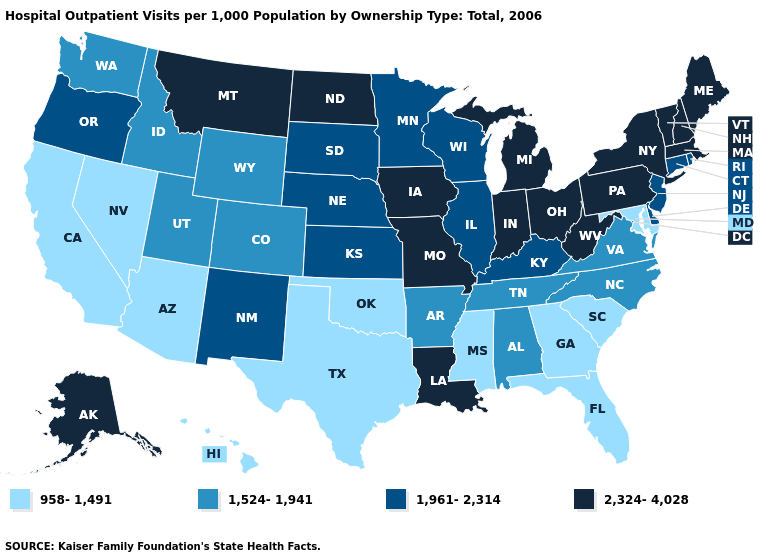Which states have the lowest value in the Northeast?
Give a very brief answer. Connecticut, New Jersey, Rhode Island. Does North Carolina have the same value as Wisconsin?
Keep it brief. No. Name the states that have a value in the range 1,961-2,314?
Be succinct. Connecticut, Delaware, Illinois, Kansas, Kentucky, Minnesota, Nebraska, New Jersey, New Mexico, Oregon, Rhode Island, South Dakota, Wisconsin. Does Oregon have the lowest value in the West?
Be succinct. No. What is the value of Massachusetts?
Answer briefly. 2,324-4,028. What is the highest value in the USA?
Short answer required. 2,324-4,028. Among the states that border Kentucky , does Ohio have the highest value?
Answer briefly. Yes. Among the states that border New Mexico , does Texas have the highest value?
Keep it brief. No. What is the value of Florida?
Quick response, please. 958-1,491. What is the value of Oregon?
Answer briefly. 1,961-2,314. Name the states that have a value in the range 1,524-1,941?
Answer briefly. Alabama, Arkansas, Colorado, Idaho, North Carolina, Tennessee, Utah, Virginia, Washington, Wyoming. Name the states that have a value in the range 958-1,491?
Write a very short answer. Arizona, California, Florida, Georgia, Hawaii, Maryland, Mississippi, Nevada, Oklahoma, South Carolina, Texas. Name the states that have a value in the range 1,961-2,314?
Answer briefly. Connecticut, Delaware, Illinois, Kansas, Kentucky, Minnesota, Nebraska, New Jersey, New Mexico, Oregon, Rhode Island, South Dakota, Wisconsin. Name the states that have a value in the range 1,524-1,941?
Quick response, please. Alabama, Arkansas, Colorado, Idaho, North Carolina, Tennessee, Utah, Virginia, Washington, Wyoming. What is the lowest value in the USA?
Concise answer only. 958-1,491. 